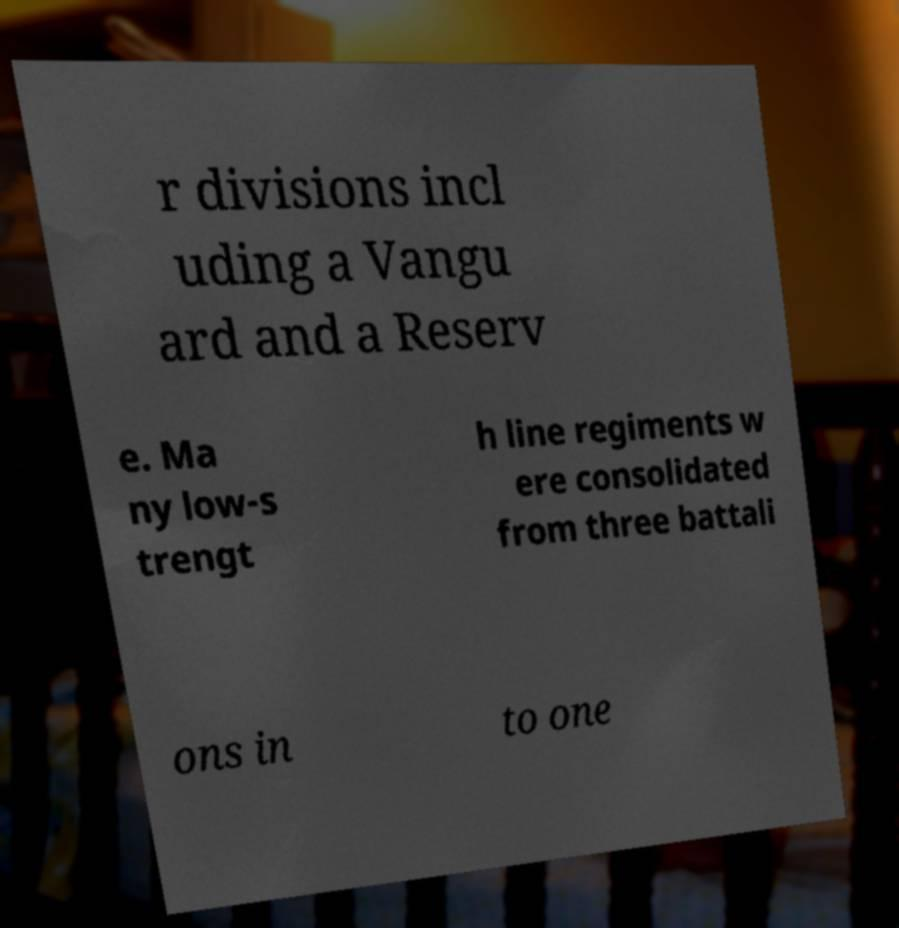Can you accurately transcribe the text from the provided image for me? r divisions incl uding a Vangu ard and a Reserv e. Ma ny low-s trengt h line regiments w ere consolidated from three battali ons in to one 